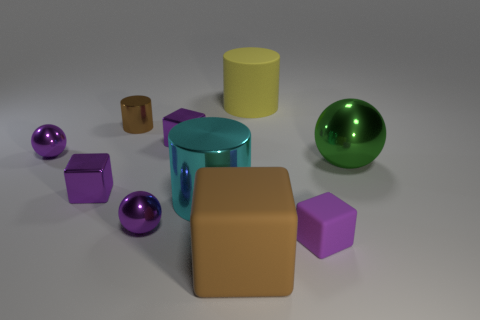Subtract all cyan balls. How many purple cubes are left? 3 Subtract all gray balls. Subtract all blue blocks. How many balls are left? 3 Subtract all cylinders. How many objects are left? 7 Subtract 1 purple spheres. How many objects are left? 9 Subtract all blue balls. Subtract all small shiny cubes. How many objects are left? 8 Add 1 purple cubes. How many purple cubes are left? 4 Add 4 purple spheres. How many purple spheres exist? 6 